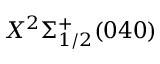<formula> <loc_0><loc_0><loc_500><loc_500>X ^ { 2 } \Sigma _ { 1 / 2 } ^ { + } ( 0 4 0 )</formula> 